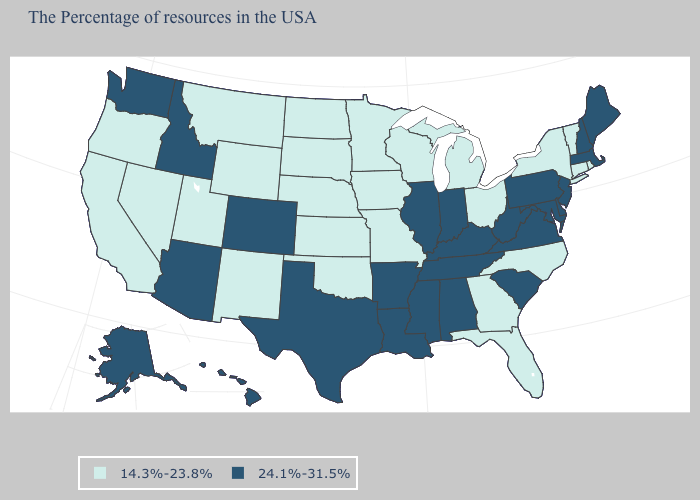Does Illinois have the highest value in the MidWest?
Give a very brief answer. Yes. What is the value of North Carolina?
Be succinct. 14.3%-23.8%. What is the value of Iowa?
Short answer required. 14.3%-23.8%. How many symbols are there in the legend?
Keep it brief. 2. What is the lowest value in states that border Wisconsin?
Quick response, please. 14.3%-23.8%. Does Florida have the highest value in the South?
Quick response, please. No. Name the states that have a value in the range 24.1%-31.5%?
Write a very short answer. Maine, Massachusetts, New Hampshire, New Jersey, Delaware, Maryland, Pennsylvania, Virginia, South Carolina, West Virginia, Kentucky, Indiana, Alabama, Tennessee, Illinois, Mississippi, Louisiana, Arkansas, Texas, Colorado, Arizona, Idaho, Washington, Alaska, Hawaii. What is the value of Alaska?
Give a very brief answer. 24.1%-31.5%. Does the first symbol in the legend represent the smallest category?
Give a very brief answer. Yes. Does the map have missing data?
Quick response, please. No. What is the value of Michigan?
Answer briefly. 14.3%-23.8%. What is the value of South Carolina?
Answer briefly. 24.1%-31.5%. What is the highest value in the USA?
Write a very short answer. 24.1%-31.5%. Name the states that have a value in the range 14.3%-23.8%?
Be succinct. Rhode Island, Vermont, Connecticut, New York, North Carolina, Ohio, Florida, Georgia, Michigan, Wisconsin, Missouri, Minnesota, Iowa, Kansas, Nebraska, Oklahoma, South Dakota, North Dakota, Wyoming, New Mexico, Utah, Montana, Nevada, California, Oregon. What is the lowest value in states that border Washington?
Short answer required. 14.3%-23.8%. 